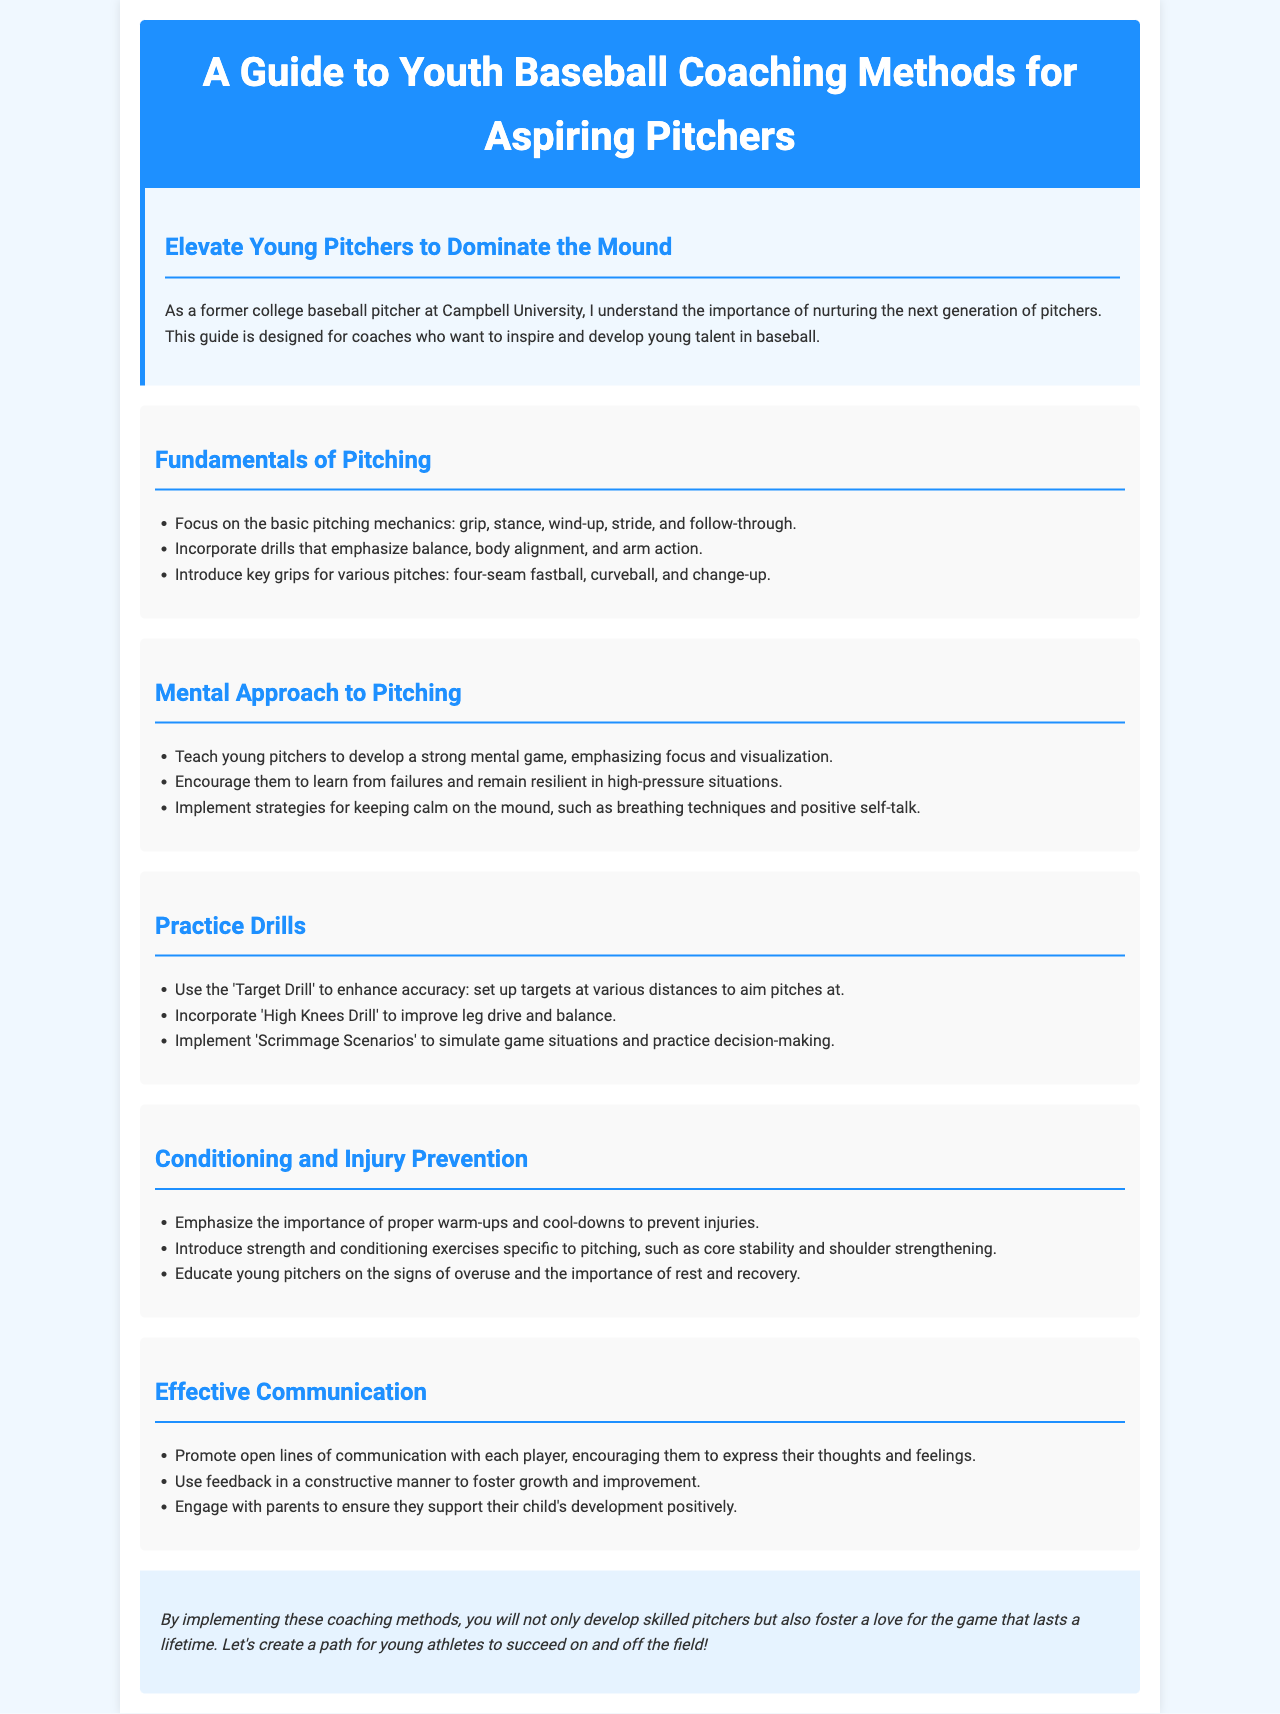what is the title of the brochure? The title is presented in the header section of the document, stating the purpose of the content.
Answer: A Guide to Youth Baseball Coaching Methods for Aspiring Pitchers who is the author of the guide? The introduction mentions the author as a former college baseball pitcher, providing credibility to the content.
Answer: A former college baseball pitcher at Campbell University what is the primary focus of the 'Fundamentals of Pitching' section? This section outlines key elements that young pitchers need to develop their skills effectively.
Answer: Basic pitching mechanics which drill aims to enhance accuracy? The document specifies a particular exercise designed to improve a player's precision on the mound.
Answer: Target Drill what mental strategy is advised for young pitchers in high-pressure situations? The document mentions specific approaches that help young athletes handle stress while pitching effectively.
Answer: Resiliency which important aspect does the 'Conditioning and Injury Prevention' section emphasize? This section provides guidance on related topics crucial for ensuring players' well-being during practices and games.
Answer: Warm-ups and cool-downs how should communication be structured according to the guide? The document highlights methods for interaction between players, coaches, and parents, essential for player development.
Answer: Open lines of communication what is the ultimate goal of implementing the coaching methods discussed? The conclusion summarizes the intended outcomes of applying the coaching techniques proposed throughout the document.
Answer: Develop skilled pitchers 